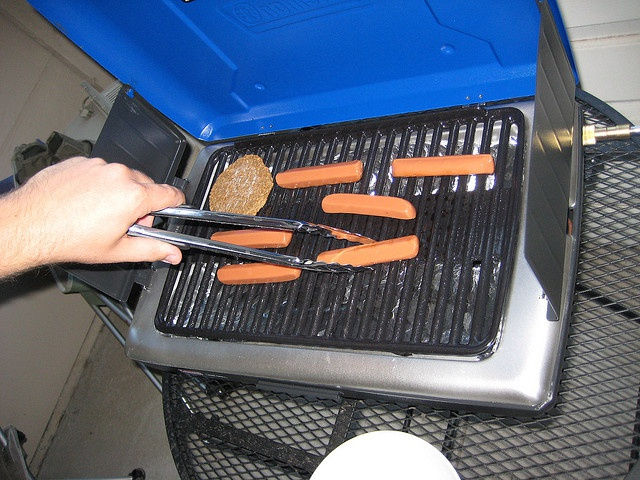Describe the objects in this image and their specific colors. I can see people in black, ivory, and tan tones, hot dog in black, tan, and salmon tones, hot dog in black, salmon, tan, and brown tones, hot dog in black, tan, salmon, and brown tones, and hot dog in black, salmon, and brown tones in this image. 